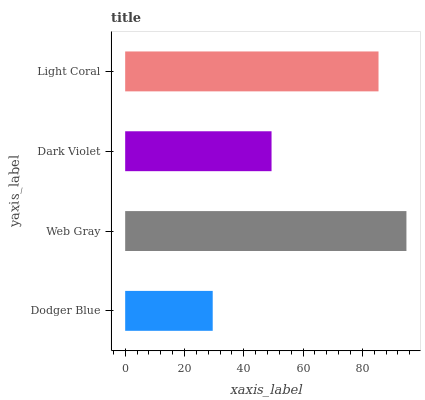Is Dodger Blue the minimum?
Answer yes or no. Yes. Is Web Gray the maximum?
Answer yes or no. Yes. Is Dark Violet the minimum?
Answer yes or no. No. Is Dark Violet the maximum?
Answer yes or no. No. Is Web Gray greater than Dark Violet?
Answer yes or no. Yes. Is Dark Violet less than Web Gray?
Answer yes or no. Yes. Is Dark Violet greater than Web Gray?
Answer yes or no. No. Is Web Gray less than Dark Violet?
Answer yes or no. No. Is Light Coral the high median?
Answer yes or no. Yes. Is Dark Violet the low median?
Answer yes or no. Yes. Is Web Gray the high median?
Answer yes or no. No. Is Light Coral the low median?
Answer yes or no. No. 